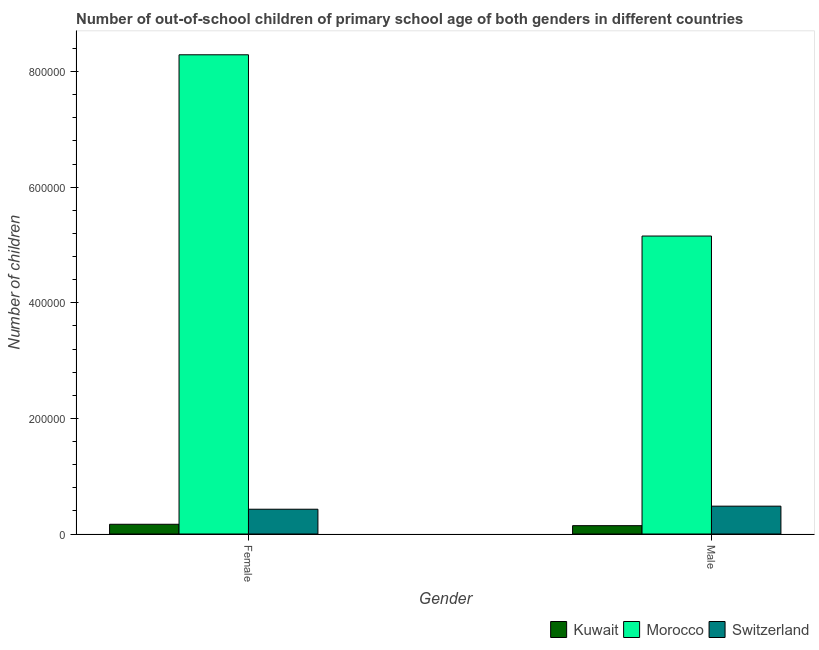How many different coloured bars are there?
Your answer should be very brief. 3. How many groups of bars are there?
Your answer should be compact. 2. How many bars are there on the 2nd tick from the left?
Your answer should be very brief. 3. How many bars are there on the 1st tick from the right?
Offer a terse response. 3. What is the label of the 1st group of bars from the left?
Provide a short and direct response. Female. What is the number of male out-of-school students in Morocco?
Ensure brevity in your answer.  5.15e+05. Across all countries, what is the maximum number of female out-of-school students?
Provide a short and direct response. 8.29e+05. Across all countries, what is the minimum number of female out-of-school students?
Provide a short and direct response. 1.68e+04. In which country was the number of female out-of-school students maximum?
Make the answer very short. Morocco. In which country was the number of female out-of-school students minimum?
Provide a short and direct response. Kuwait. What is the total number of female out-of-school students in the graph?
Provide a short and direct response. 8.89e+05. What is the difference between the number of female out-of-school students in Kuwait and that in Switzerland?
Your answer should be very brief. -2.60e+04. What is the difference between the number of female out-of-school students in Kuwait and the number of male out-of-school students in Switzerland?
Keep it short and to the point. -3.13e+04. What is the average number of female out-of-school students per country?
Your response must be concise. 2.96e+05. What is the difference between the number of female out-of-school students and number of male out-of-school students in Morocco?
Make the answer very short. 3.14e+05. What is the ratio of the number of female out-of-school students in Kuwait to that in Morocco?
Give a very brief answer. 0.02. Is the number of female out-of-school students in Switzerland less than that in Morocco?
Provide a succinct answer. Yes. What does the 1st bar from the left in Female represents?
Keep it short and to the point. Kuwait. What does the 1st bar from the right in Female represents?
Offer a very short reply. Switzerland. Are all the bars in the graph horizontal?
Provide a succinct answer. No. What is the difference between two consecutive major ticks on the Y-axis?
Offer a very short reply. 2.00e+05. Does the graph contain any zero values?
Offer a terse response. No. Does the graph contain grids?
Your answer should be compact. No. Where does the legend appear in the graph?
Keep it short and to the point. Bottom right. How are the legend labels stacked?
Your answer should be very brief. Horizontal. What is the title of the graph?
Provide a short and direct response. Number of out-of-school children of primary school age of both genders in different countries. Does "Romania" appear as one of the legend labels in the graph?
Your answer should be very brief. No. What is the label or title of the X-axis?
Your answer should be compact. Gender. What is the label or title of the Y-axis?
Ensure brevity in your answer.  Number of children. What is the Number of children in Kuwait in Female?
Ensure brevity in your answer.  1.68e+04. What is the Number of children in Morocco in Female?
Offer a very short reply. 8.29e+05. What is the Number of children in Switzerland in Female?
Offer a terse response. 4.29e+04. What is the Number of children in Kuwait in Male?
Your answer should be compact. 1.44e+04. What is the Number of children of Morocco in Male?
Ensure brevity in your answer.  5.15e+05. What is the Number of children in Switzerland in Male?
Provide a succinct answer. 4.81e+04. Across all Gender, what is the maximum Number of children of Kuwait?
Your answer should be compact. 1.68e+04. Across all Gender, what is the maximum Number of children of Morocco?
Ensure brevity in your answer.  8.29e+05. Across all Gender, what is the maximum Number of children in Switzerland?
Keep it short and to the point. 4.81e+04. Across all Gender, what is the minimum Number of children in Kuwait?
Ensure brevity in your answer.  1.44e+04. Across all Gender, what is the minimum Number of children of Morocco?
Ensure brevity in your answer.  5.15e+05. Across all Gender, what is the minimum Number of children in Switzerland?
Make the answer very short. 4.29e+04. What is the total Number of children in Kuwait in the graph?
Provide a short and direct response. 3.13e+04. What is the total Number of children in Morocco in the graph?
Ensure brevity in your answer.  1.34e+06. What is the total Number of children of Switzerland in the graph?
Offer a terse response. 9.10e+04. What is the difference between the Number of children in Kuwait in Female and that in Male?
Provide a short and direct response. 2402. What is the difference between the Number of children of Morocco in Female and that in Male?
Your answer should be very brief. 3.14e+05. What is the difference between the Number of children of Switzerland in Female and that in Male?
Give a very brief answer. -5292. What is the difference between the Number of children of Kuwait in Female and the Number of children of Morocco in Male?
Offer a very short reply. -4.99e+05. What is the difference between the Number of children of Kuwait in Female and the Number of children of Switzerland in Male?
Your answer should be very brief. -3.13e+04. What is the difference between the Number of children of Morocco in Female and the Number of children of Switzerland in Male?
Offer a terse response. 7.81e+05. What is the average Number of children in Kuwait per Gender?
Give a very brief answer. 1.56e+04. What is the average Number of children in Morocco per Gender?
Provide a short and direct response. 6.72e+05. What is the average Number of children in Switzerland per Gender?
Your answer should be very brief. 4.55e+04. What is the difference between the Number of children in Kuwait and Number of children in Morocco in Female?
Your answer should be compact. -8.12e+05. What is the difference between the Number of children in Kuwait and Number of children in Switzerland in Female?
Your answer should be compact. -2.60e+04. What is the difference between the Number of children of Morocco and Number of children of Switzerland in Female?
Offer a very short reply. 7.86e+05. What is the difference between the Number of children of Kuwait and Number of children of Morocco in Male?
Offer a very short reply. -5.01e+05. What is the difference between the Number of children in Kuwait and Number of children in Switzerland in Male?
Your answer should be compact. -3.37e+04. What is the difference between the Number of children in Morocco and Number of children in Switzerland in Male?
Provide a short and direct response. 4.67e+05. What is the ratio of the Number of children in Kuwait in Female to that in Male?
Your answer should be compact. 1.17. What is the ratio of the Number of children in Morocco in Female to that in Male?
Keep it short and to the point. 1.61. What is the ratio of the Number of children in Switzerland in Female to that in Male?
Your answer should be compact. 0.89. What is the difference between the highest and the second highest Number of children of Kuwait?
Your answer should be very brief. 2402. What is the difference between the highest and the second highest Number of children of Morocco?
Offer a terse response. 3.14e+05. What is the difference between the highest and the second highest Number of children in Switzerland?
Your response must be concise. 5292. What is the difference between the highest and the lowest Number of children of Kuwait?
Make the answer very short. 2402. What is the difference between the highest and the lowest Number of children of Morocco?
Your answer should be very brief. 3.14e+05. What is the difference between the highest and the lowest Number of children of Switzerland?
Make the answer very short. 5292. 